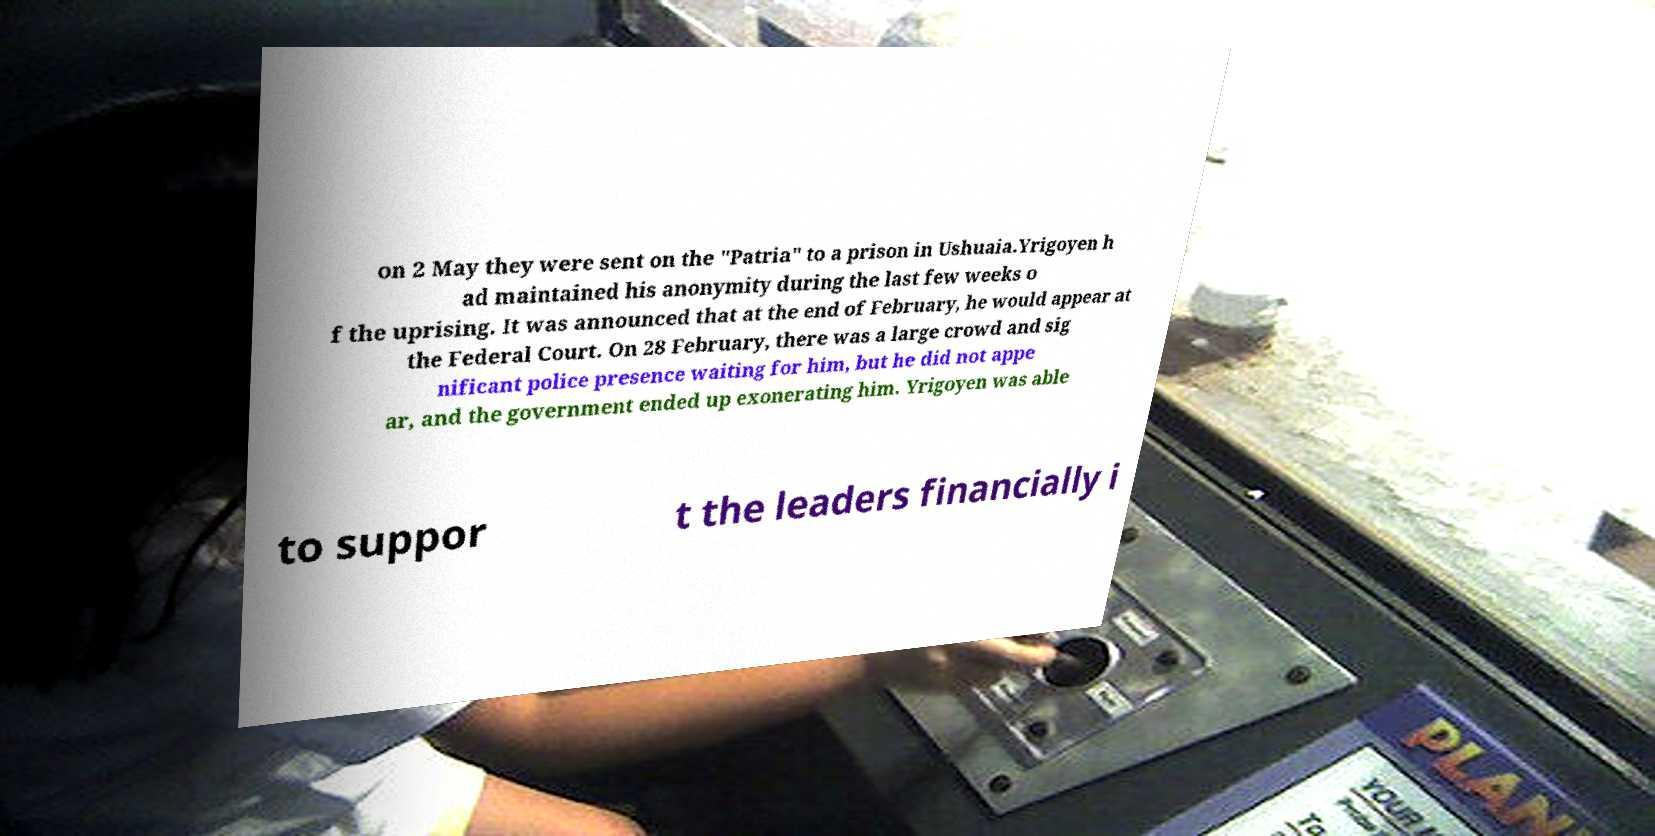Could you extract and type out the text from this image? on 2 May they were sent on the "Patria" to a prison in Ushuaia.Yrigoyen h ad maintained his anonymity during the last few weeks o f the uprising. It was announced that at the end of February, he would appear at the Federal Court. On 28 February, there was a large crowd and sig nificant police presence waiting for him, but he did not appe ar, and the government ended up exonerating him. Yrigoyen was able to suppor t the leaders financially i 